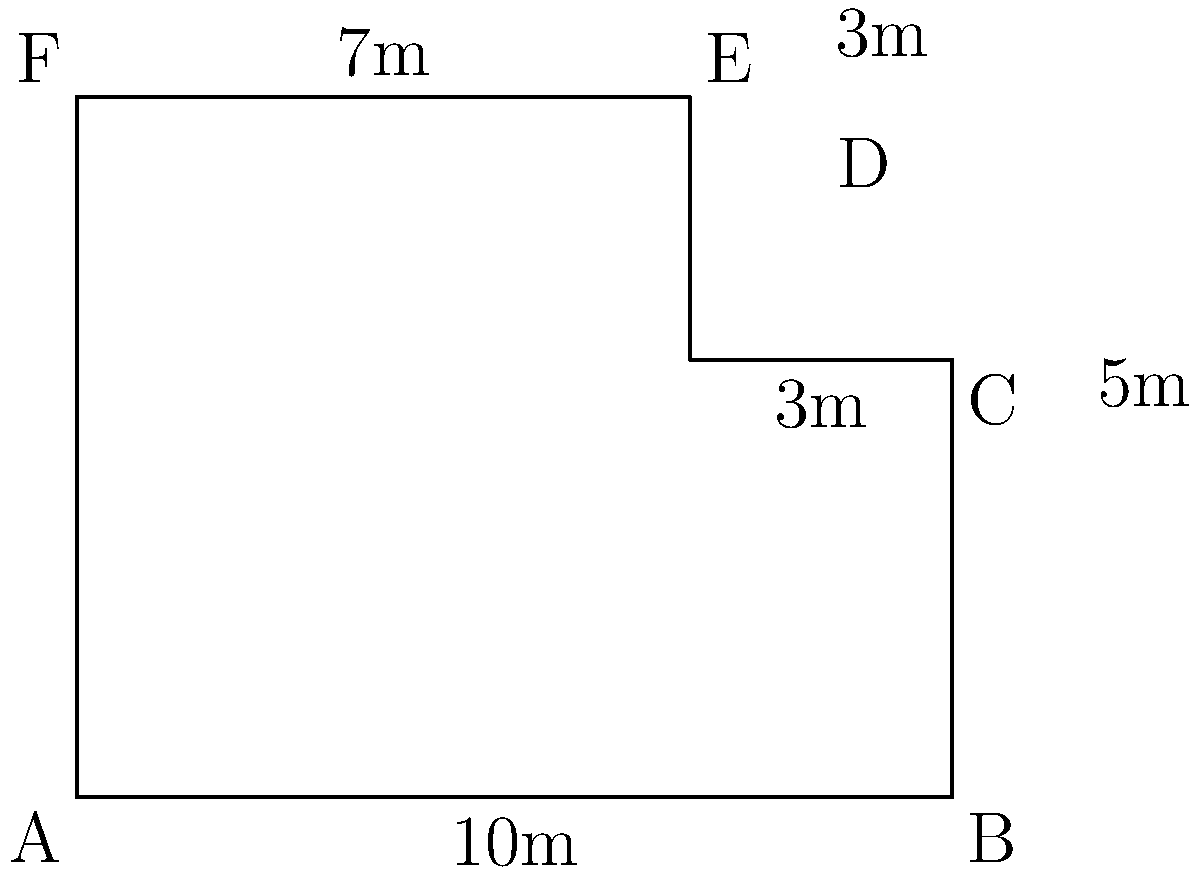As a pet sitter, you're tasked with designing a new dog park for your client's rescue dog. The park has an irregular shape as shown in the diagram. Calculate the total area of the dog park in square meters. To calculate the total area, we'll divide the shape into rectangles and a triangle:

1. Rectangle ABCF:
   Area = $10 \text{ m} \times 5 \text{ m} = 50 \text{ m}^2$

2. Rectangle DEFC:
   Area = $7 \text{ m} \times 3 \text{ m} = 21 \text{ m}^2$

3. Triangle CDE:
   Base = $3 \text{ m}$, Height = $3 \text{ m}$
   Area = $\frac{1}{2} \times 3 \text{ m} \times 3 \text{ m} = 4.5 \text{ m}^2$

Total area:
$$ \text{Total Area} = 50 \text{ m}^2 + 21 \text{ m}^2 + 4.5 \text{ m}^2 = 75.5 \text{ m}^2 $$
Answer: $75.5 \text{ m}^2$ 